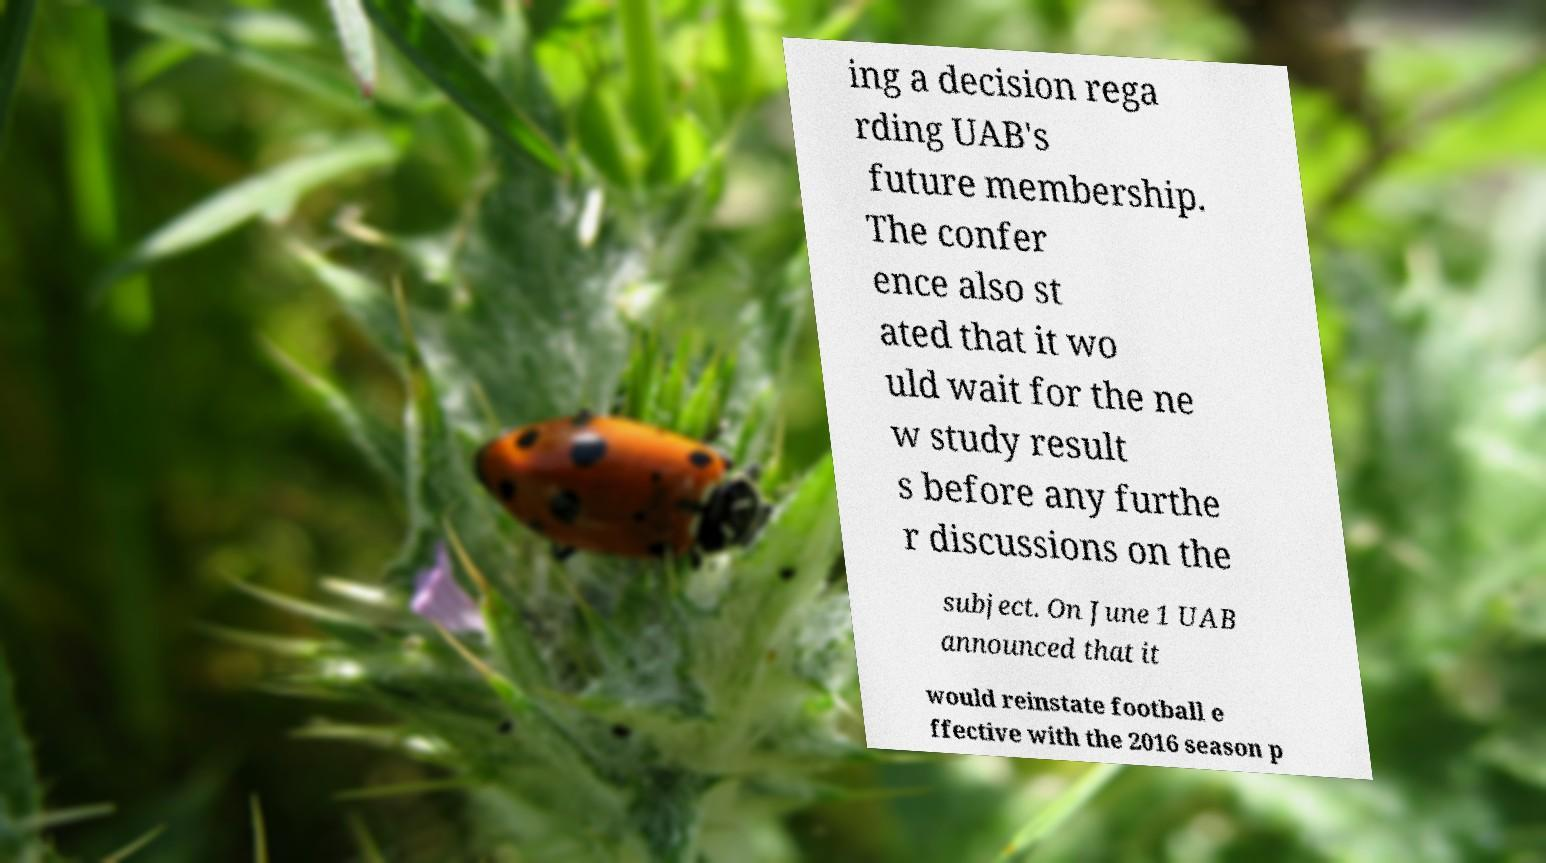What messages or text are displayed in this image? I need them in a readable, typed format. ing a decision rega rding UAB's future membership. The confer ence also st ated that it wo uld wait for the ne w study result s before any furthe r discussions on the subject. On June 1 UAB announced that it would reinstate football e ffective with the 2016 season p 